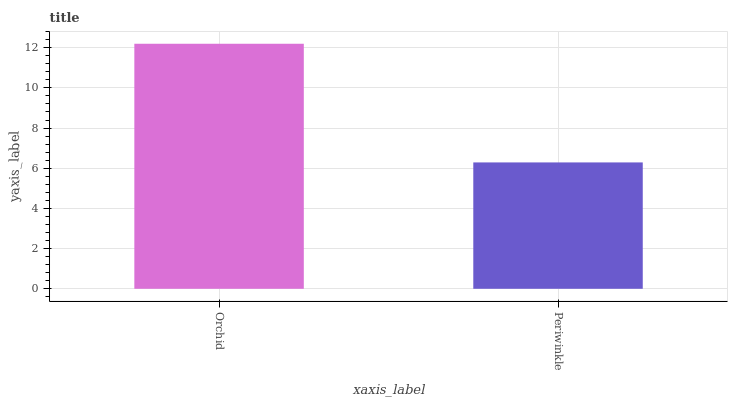Is Periwinkle the minimum?
Answer yes or no. Yes. Is Orchid the maximum?
Answer yes or no. Yes. Is Periwinkle the maximum?
Answer yes or no. No. Is Orchid greater than Periwinkle?
Answer yes or no. Yes. Is Periwinkle less than Orchid?
Answer yes or no. Yes. Is Periwinkle greater than Orchid?
Answer yes or no. No. Is Orchid less than Periwinkle?
Answer yes or no. No. Is Orchid the high median?
Answer yes or no. Yes. Is Periwinkle the low median?
Answer yes or no. Yes. Is Periwinkle the high median?
Answer yes or no. No. Is Orchid the low median?
Answer yes or no. No. 